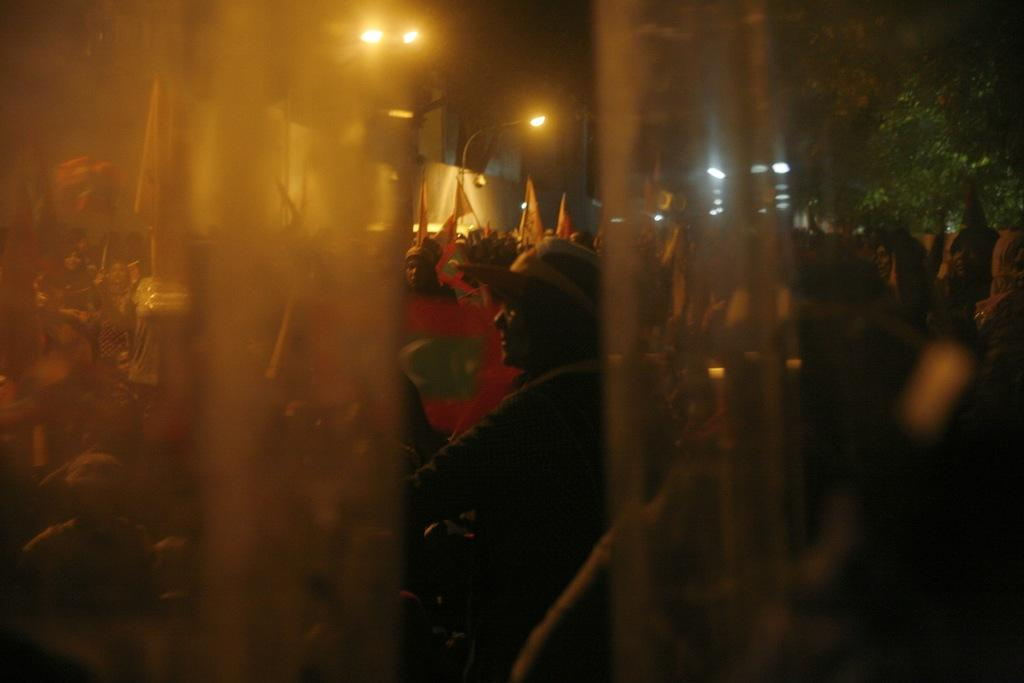What is present in the image that can be used for privacy or decoration? There is a curtain in the image that can be used for privacy or decoration. What can be seen through the curtain? People are visible through the curtain. What are the people holding in the image? The people are holding flags. What can be seen in the background of the image? There are poles and trees visible in the background. What type of hole can be seen in the curtain in the image? There is no hole present in the curtain in the image. What kind of yarn is being used to create the flags in the image? The image does not provide information about the type of yarn used to create the flags. 